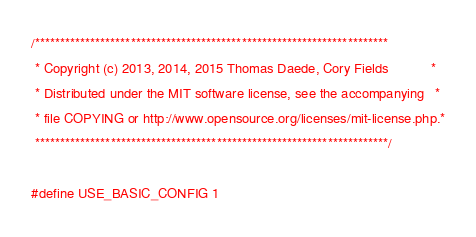Convert code to text. <code><loc_0><loc_0><loc_500><loc_500><_C_>/**********************************************************************
 * Copyright (c) 2013, 2014, 2015 Thomas Daede, Cory Fields           *
 * Distributed under the MIT software license, see the accompanying   *
 * file COPYING or http://www.opensource.org/licenses/mit-license.php.*
 **********************************************************************/

#define USE_BASIC_CONFIG 1
</code> 